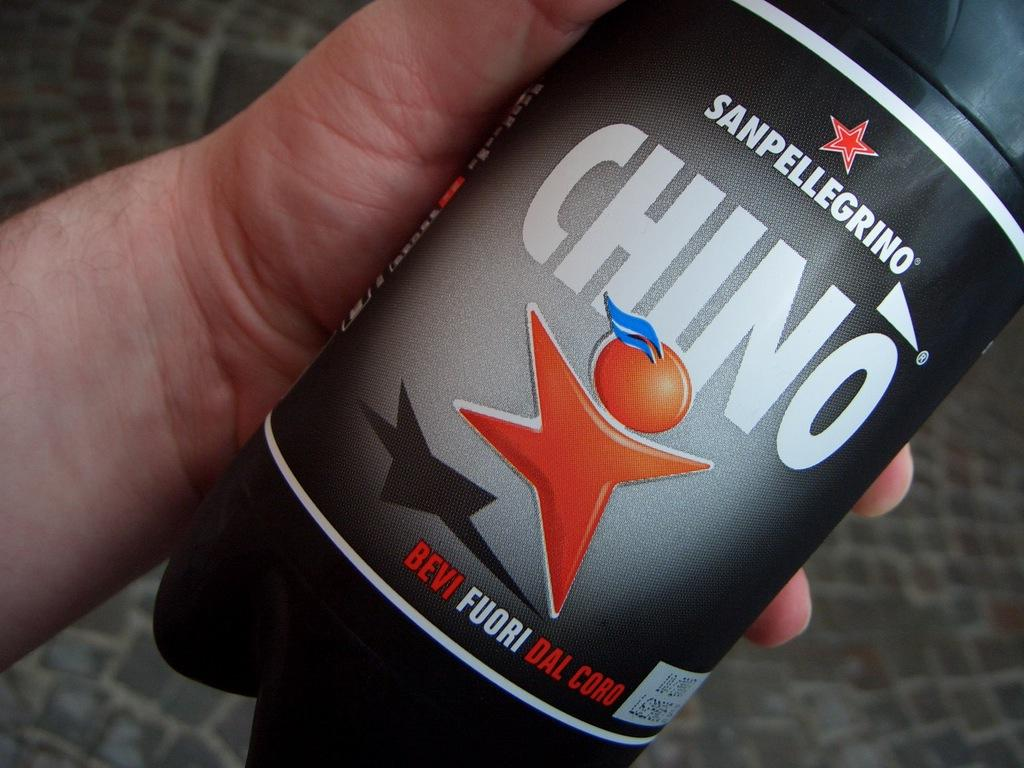<image>
Write a terse but informative summary of the picture. A man holds a bottle of Chino in his hand. 